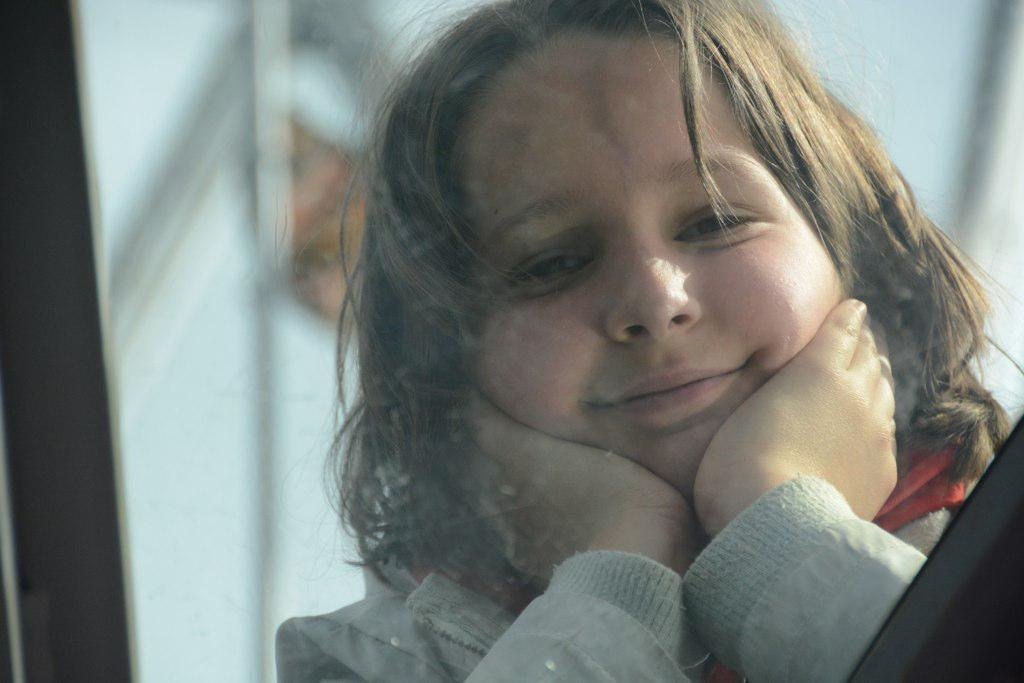Who is the main subject in the picture? There is a girl in the picture. What is the girl's expression in the image? The girl is smiling. What is the girl wearing in the picture? The girl is wearing a sweater. Can you describe the backdrop of the picture? There is a black frame and a white color wall in the backdrop, and the backdrop is blurred. What type of slave is depicted in the picture? There is no slave depicted in the picture; it features a smiling girl wearing a sweater. What kind of party is taking place in the image? There is no party depicted in the image; it is a portrait of a girl. 